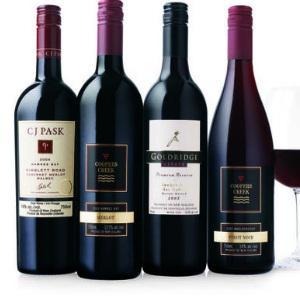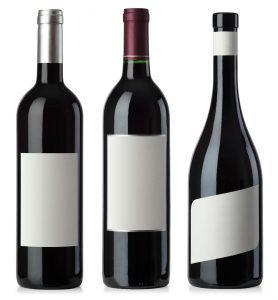The first image is the image on the left, the second image is the image on the right. For the images shown, is this caption "The left image contains exactly four bottles of wine." true? Answer yes or no. Yes. The first image is the image on the left, the second image is the image on the right. Assess this claim about the two images: "Exactly three bottles are displayed in a level row with none of them touching or overlapping.". Correct or not? Answer yes or no. Yes. 